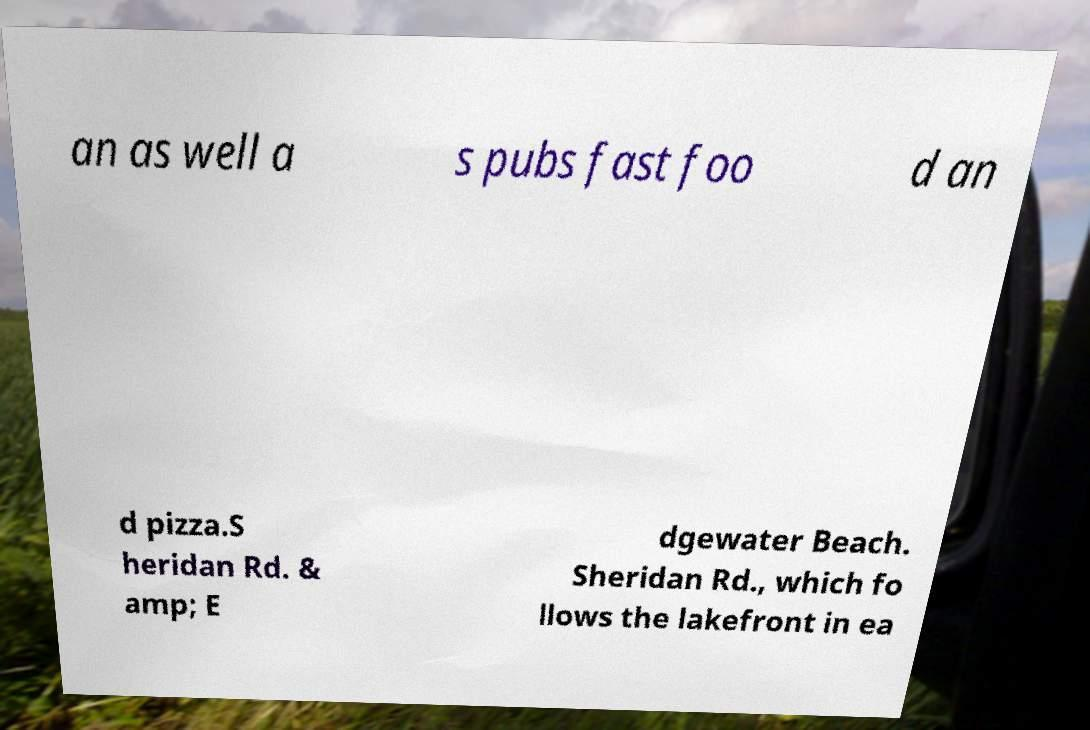I need the written content from this picture converted into text. Can you do that? an as well a s pubs fast foo d an d pizza.S heridan Rd. & amp; E dgewater Beach. Sheridan Rd., which fo llows the lakefront in ea 